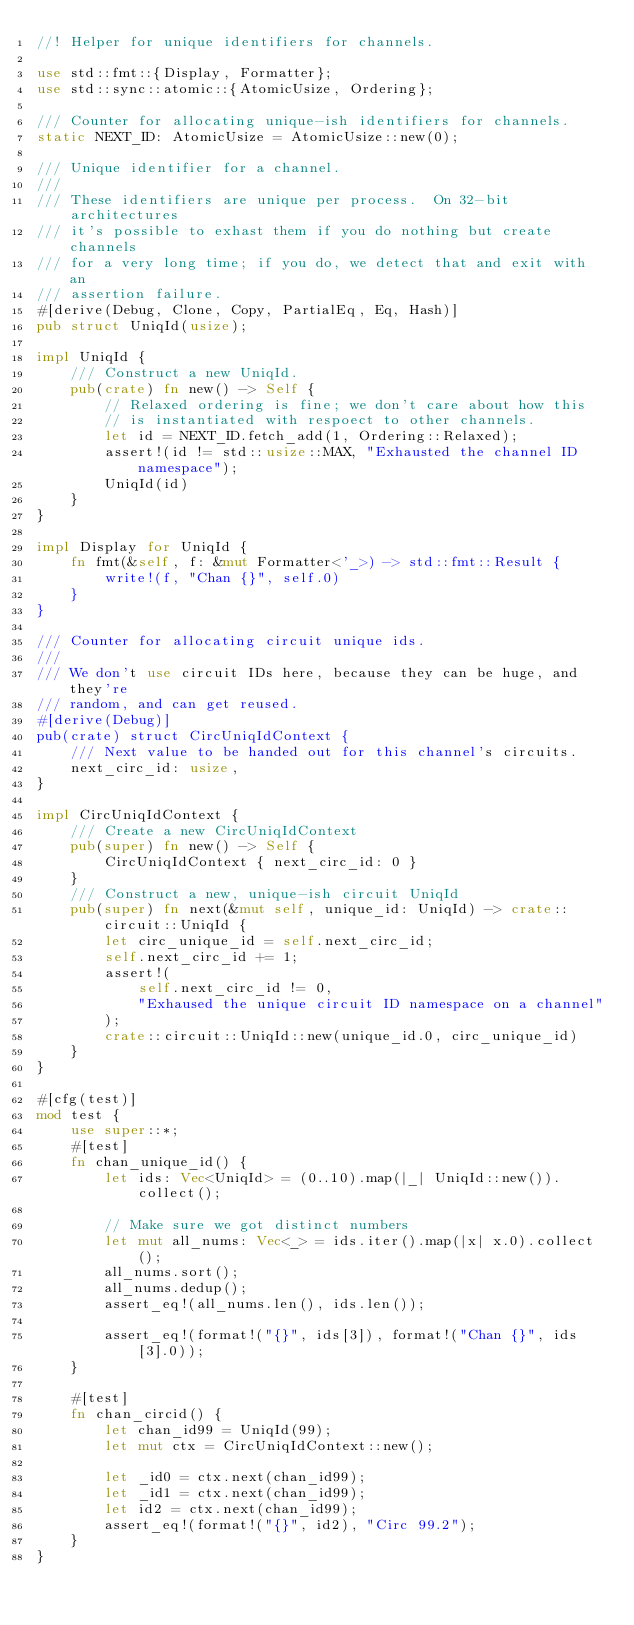Convert code to text. <code><loc_0><loc_0><loc_500><loc_500><_Rust_>//! Helper for unique identifiers for channels.

use std::fmt::{Display, Formatter};
use std::sync::atomic::{AtomicUsize, Ordering};

/// Counter for allocating unique-ish identifiers for channels.
static NEXT_ID: AtomicUsize = AtomicUsize::new(0);

/// Unique identifier for a channel.
///
/// These identifiers are unique per process.  On 32-bit architectures
/// it's possible to exhast them if you do nothing but create channels
/// for a very long time; if you do, we detect that and exit with an
/// assertion failure.
#[derive(Debug, Clone, Copy, PartialEq, Eq, Hash)]
pub struct UniqId(usize);

impl UniqId {
    /// Construct a new UniqId.
    pub(crate) fn new() -> Self {
        // Relaxed ordering is fine; we don't care about how this
        // is instantiated with respoect to other channels.
        let id = NEXT_ID.fetch_add(1, Ordering::Relaxed);
        assert!(id != std::usize::MAX, "Exhausted the channel ID namespace");
        UniqId(id)
    }
}

impl Display for UniqId {
    fn fmt(&self, f: &mut Formatter<'_>) -> std::fmt::Result {
        write!(f, "Chan {}", self.0)
    }
}

/// Counter for allocating circuit unique ids.
///
/// We don't use circuit IDs here, because they can be huge, and they're
/// random, and can get reused.
#[derive(Debug)]
pub(crate) struct CircUniqIdContext {
    /// Next value to be handed out for this channel's circuits.
    next_circ_id: usize,
}

impl CircUniqIdContext {
    /// Create a new CircUniqIdContext
    pub(super) fn new() -> Self {
        CircUniqIdContext { next_circ_id: 0 }
    }
    /// Construct a new, unique-ish circuit UniqId
    pub(super) fn next(&mut self, unique_id: UniqId) -> crate::circuit::UniqId {
        let circ_unique_id = self.next_circ_id;
        self.next_circ_id += 1;
        assert!(
            self.next_circ_id != 0,
            "Exhaused the unique circuit ID namespace on a channel"
        );
        crate::circuit::UniqId::new(unique_id.0, circ_unique_id)
    }
}

#[cfg(test)]
mod test {
    use super::*;
    #[test]
    fn chan_unique_id() {
        let ids: Vec<UniqId> = (0..10).map(|_| UniqId::new()).collect();

        // Make sure we got distinct numbers
        let mut all_nums: Vec<_> = ids.iter().map(|x| x.0).collect();
        all_nums.sort();
        all_nums.dedup();
        assert_eq!(all_nums.len(), ids.len());

        assert_eq!(format!("{}", ids[3]), format!("Chan {}", ids[3].0));
    }

    #[test]
    fn chan_circid() {
        let chan_id99 = UniqId(99);
        let mut ctx = CircUniqIdContext::new();

        let _id0 = ctx.next(chan_id99);
        let _id1 = ctx.next(chan_id99);
        let id2 = ctx.next(chan_id99);
        assert_eq!(format!("{}", id2), "Circ 99.2");
    }
}
</code> 